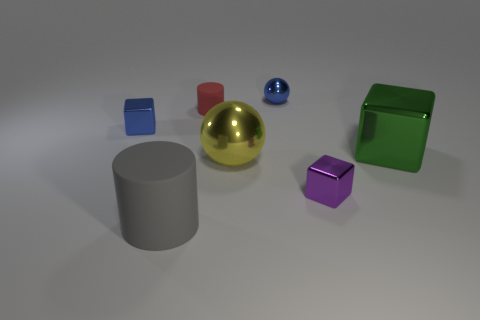Subtract all tiny blocks. How many blocks are left? 1 Subtract 2 spheres. How many spheres are left? 0 Add 1 blue balls. How many objects exist? 8 Subtract all gray cylinders. How many cylinders are left? 1 Subtract 0 red blocks. How many objects are left? 7 Subtract all blocks. How many objects are left? 4 Subtract all red cylinders. Subtract all gray balls. How many cylinders are left? 1 Subtract all yellow metallic spheres. Subtract all metal balls. How many objects are left? 4 Add 3 small metallic objects. How many small metallic objects are left? 6 Add 6 gray matte things. How many gray matte things exist? 7 